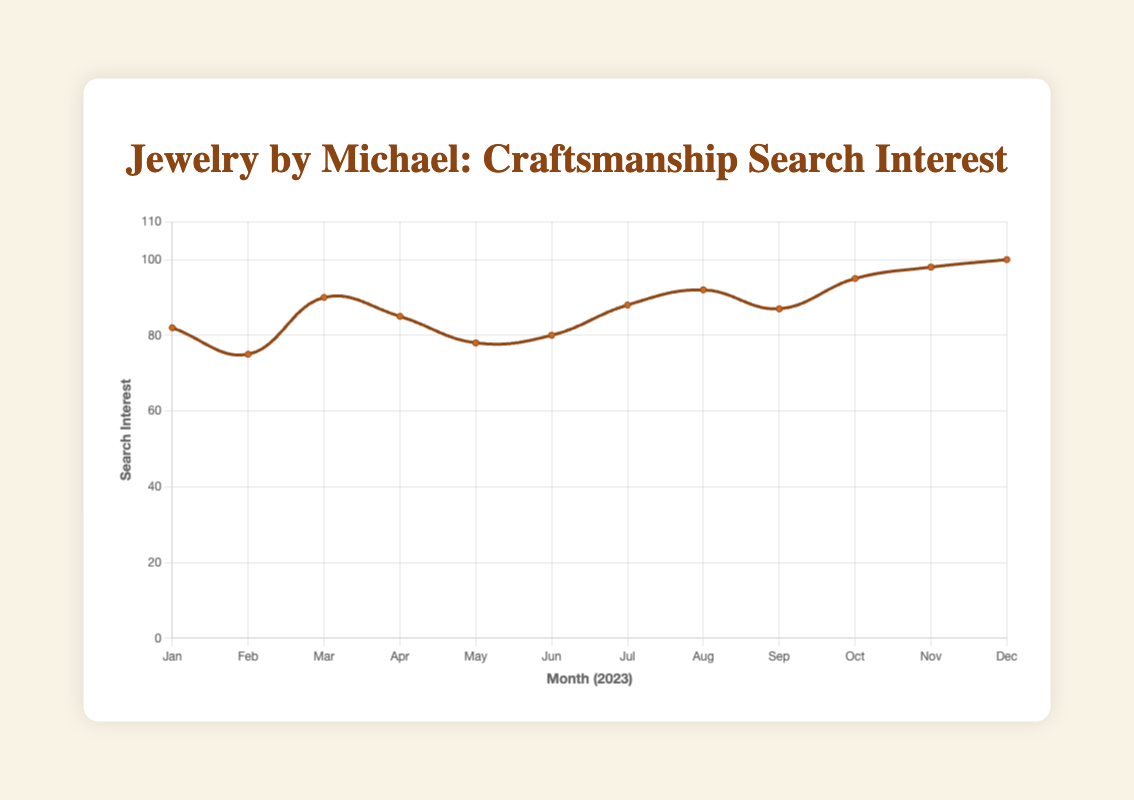What's the highest search interest value, and in which month did it occur? The highest point on the graph, which represents the search interest, is 100. This value occurs in December.
Answer: December, 100 What's the lowest search interest value, and in which month did it occur? The lowest point on the graph, which represents the search interest, is 75. This value occurs in February.
Answer: February, 75 Which months have a search interest above 90? By looking at the vertical axis and aligning it with the data points above the 90 mark, we can see that August, October, November, and December have search interests above 90.
Answer: August, October, November, and December What's the average search interest for the first half of the year (January to June)? Sum the search interest values from January to June (82 + 75 + 90 + 85 + 78 + 80), which equals 490. Divide by 6 (the number of months in the first half): 490/6 ≈ 81.67.
Answer: 81.67 Which month saw the greatest increase in search interest from the previous month? The differences in search interest between consecutive months are: February (-7), March (+15), April (-5), May (-7), June (+2), July (+8), August (+4), September (-5), October (+8), November (+3), December (+2). March had the greatest increase with a difference of +15 from February.
Answer: March How does the search interest in April compare to July? In April, the search interest is 85, and in July, it is 88. By comparing these values, we see that July has a higher search interest than April.
Answer: July is higher What's the average search interest for the entire year? Sum all the search interest values (82 + 75 + 90 + 85 + 78 + 80 + 88 + 92 + 87 + 95 + 98 + 100), which equals 1050. Divide by 12 (the number of months): 1050/12 ≈ 87.5.
Answer: 87.5 During which months does the search interest exceed the average value for the entire year? The average search interest for the year is 87.5. Comparing each month to this value, we find that the months with search interest values exceeding 87.5 are March (90), July (88), August (92), October (95), November (98), and December (100).
Answer: March, July, August, October, November, December What's the total increase in search interest from January to December? Subtract the search interest in January from the search interest in December: 100 - 82 = 18.
Answer: 18 